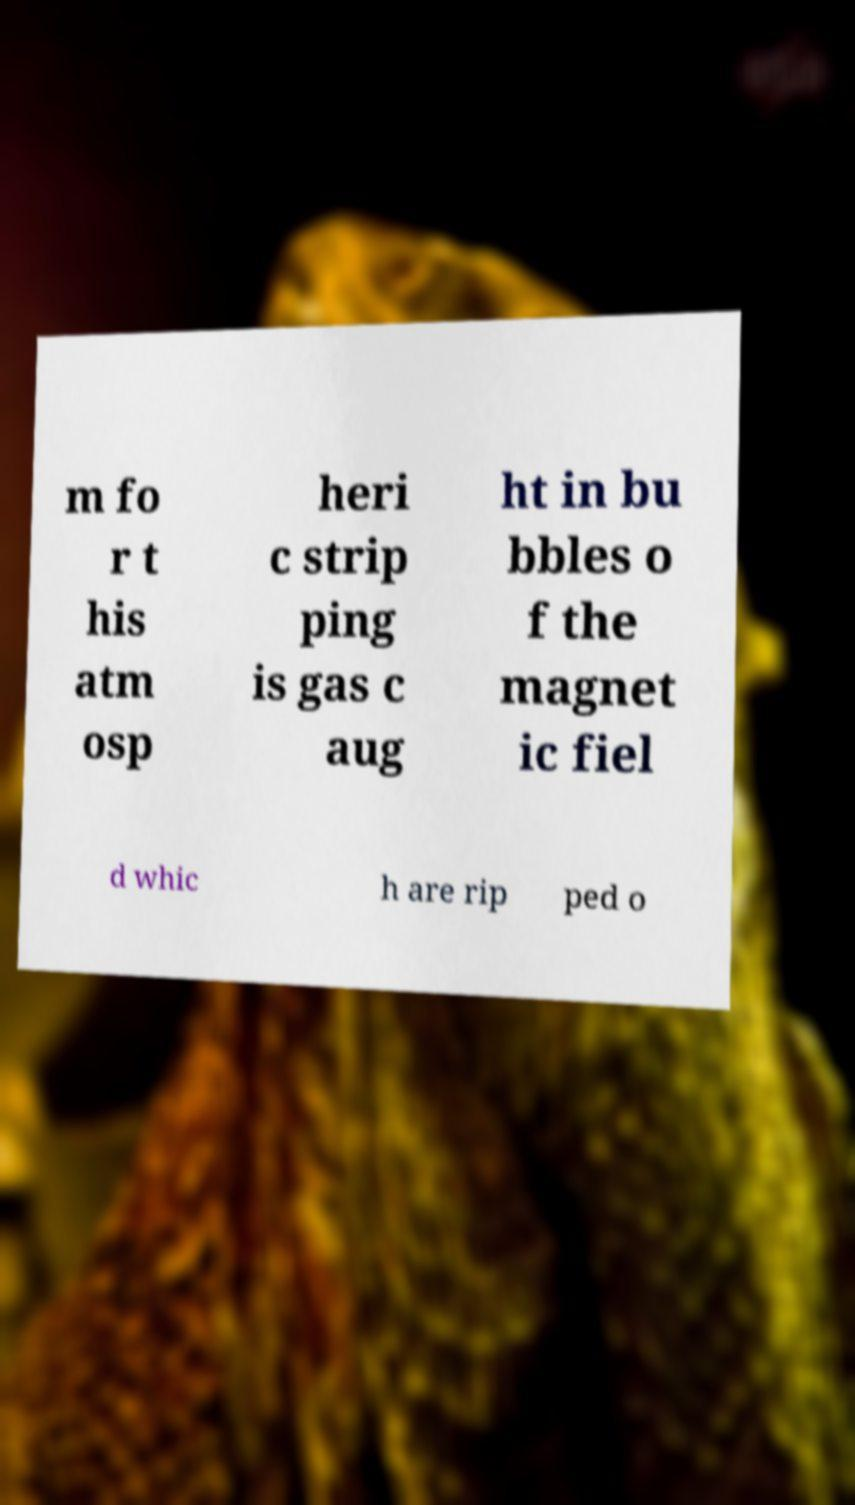There's text embedded in this image that I need extracted. Can you transcribe it verbatim? m fo r t his atm osp heri c strip ping is gas c aug ht in bu bbles o f the magnet ic fiel d whic h are rip ped o 